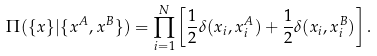Convert formula to latex. <formula><loc_0><loc_0><loc_500><loc_500>\Pi ( \{ x \} | { \{ x ^ { A } , x ^ { B } \} } ) = \prod _ { i = 1 } ^ { N } \left [ \frac { 1 } { 2 } \delta ( x _ { i } , x _ { i } ^ { A } ) + \frac { 1 } { 2 } \delta ( x _ { i } , x _ { i } ^ { B } ) \right ] .</formula> 